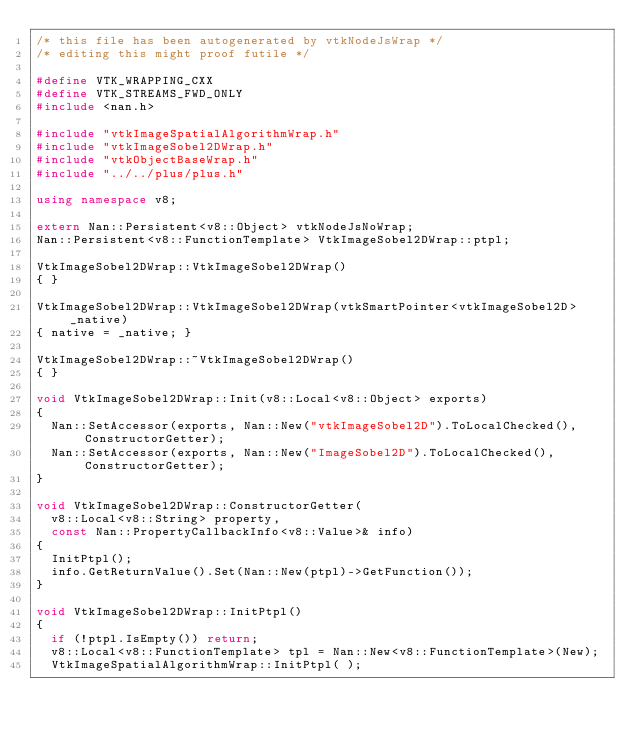Convert code to text. <code><loc_0><loc_0><loc_500><loc_500><_C++_>/* this file has been autogenerated by vtkNodeJsWrap */
/* editing this might proof futile */

#define VTK_WRAPPING_CXX
#define VTK_STREAMS_FWD_ONLY
#include <nan.h>

#include "vtkImageSpatialAlgorithmWrap.h"
#include "vtkImageSobel2DWrap.h"
#include "vtkObjectBaseWrap.h"
#include "../../plus/plus.h"

using namespace v8;

extern Nan::Persistent<v8::Object> vtkNodeJsNoWrap;
Nan::Persistent<v8::FunctionTemplate> VtkImageSobel2DWrap::ptpl;

VtkImageSobel2DWrap::VtkImageSobel2DWrap()
{ }

VtkImageSobel2DWrap::VtkImageSobel2DWrap(vtkSmartPointer<vtkImageSobel2D> _native)
{ native = _native; }

VtkImageSobel2DWrap::~VtkImageSobel2DWrap()
{ }

void VtkImageSobel2DWrap::Init(v8::Local<v8::Object> exports)
{
	Nan::SetAccessor(exports, Nan::New("vtkImageSobel2D").ToLocalChecked(), ConstructorGetter);
	Nan::SetAccessor(exports, Nan::New("ImageSobel2D").ToLocalChecked(), ConstructorGetter);
}

void VtkImageSobel2DWrap::ConstructorGetter(
	v8::Local<v8::String> property,
	const Nan::PropertyCallbackInfo<v8::Value>& info)
{
	InitPtpl();
	info.GetReturnValue().Set(Nan::New(ptpl)->GetFunction());
}

void VtkImageSobel2DWrap::InitPtpl()
{
	if (!ptpl.IsEmpty()) return;
	v8::Local<v8::FunctionTemplate> tpl = Nan::New<v8::FunctionTemplate>(New);
	VtkImageSpatialAlgorithmWrap::InitPtpl( );</code> 